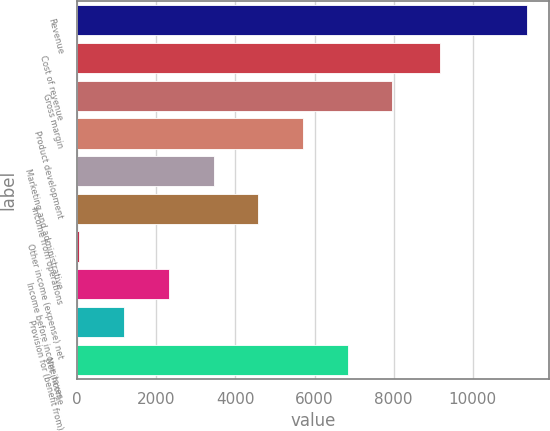<chart> <loc_0><loc_0><loc_500><loc_500><bar_chart><fcel>Revenue<fcel>Cost of revenue<fcel>Gross margin<fcel>Product development<fcel>Marketing and administrative<fcel>Income from operations<fcel>Other income (expense) net<fcel>Income before income taxes<fcel>Provision for (benefit from)<fcel>Net income<nl><fcel>11360<fcel>9175<fcel>7967.9<fcel>5706.5<fcel>3445.1<fcel>4575.8<fcel>53<fcel>2314.4<fcel>1183.7<fcel>6837.2<nl></chart> 